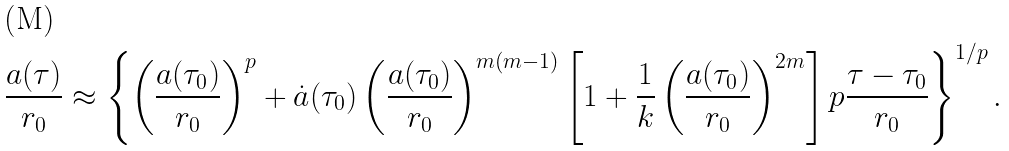<formula> <loc_0><loc_0><loc_500><loc_500>\frac { a ( \tau ) } { r _ { 0 } } \approx \left \{ \left ( \frac { a ( \tau _ { 0 } ) } { r _ { 0 } } \right ) ^ { p } + \dot { a } ( \tau _ { 0 } ) \left ( \frac { a ( \tau _ { 0 } ) } { r _ { 0 } } \right ) ^ { m ( m - 1 ) } \left [ 1 + \frac { 1 } { k } \left ( \frac { a ( \tau _ { 0 } ) } { r _ { 0 } } \right ) ^ { 2 m } \right ] p \frac { \tau - \tau _ { 0 } } { r _ { 0 } } \right \} ^ { 1 / p } .</formula> 